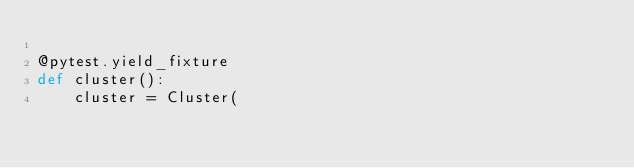<code> <loc_0><loc_0><loc_500><loc_500><_Python_>
@pytest.yield_fixture
def cluster():
    cluster = Cluster(</code> 